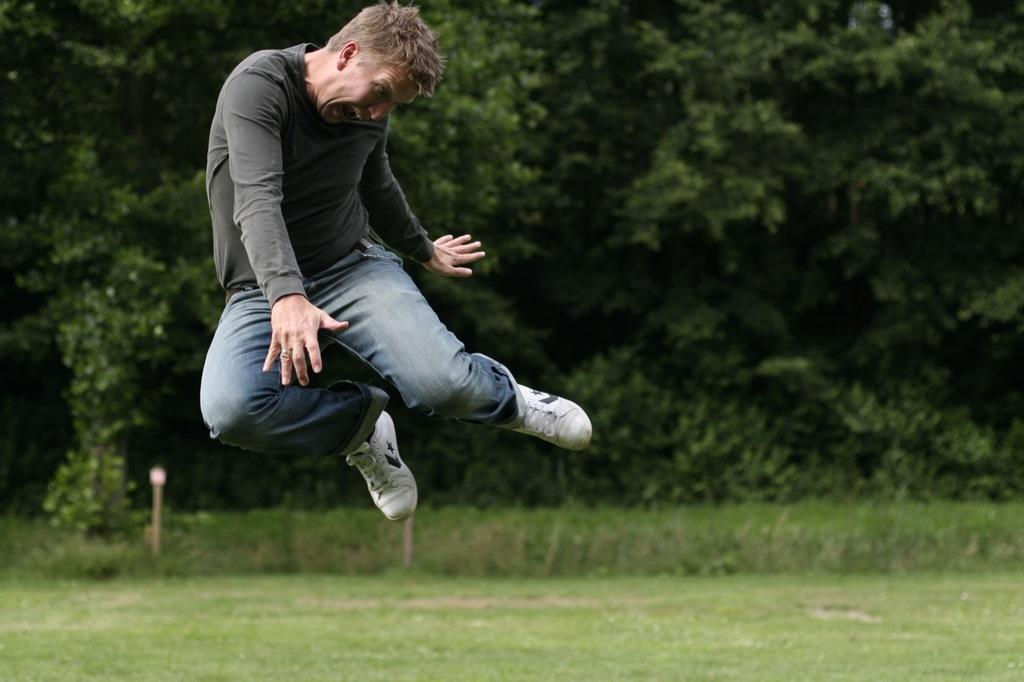What is the man doing in the image? The man is in the air in the image. What type of surface is on the ground in the image? There is grass on the ground in the image. What other natural elements can be seen in the image? There are trees visible in the image. What type of building is visible in the image? There is no building present in the image; it features a man in the air and natural elements like grass and trees. What type of stage is the man performing on in the image? There is no stage present in the image; the man is simply in the air. 